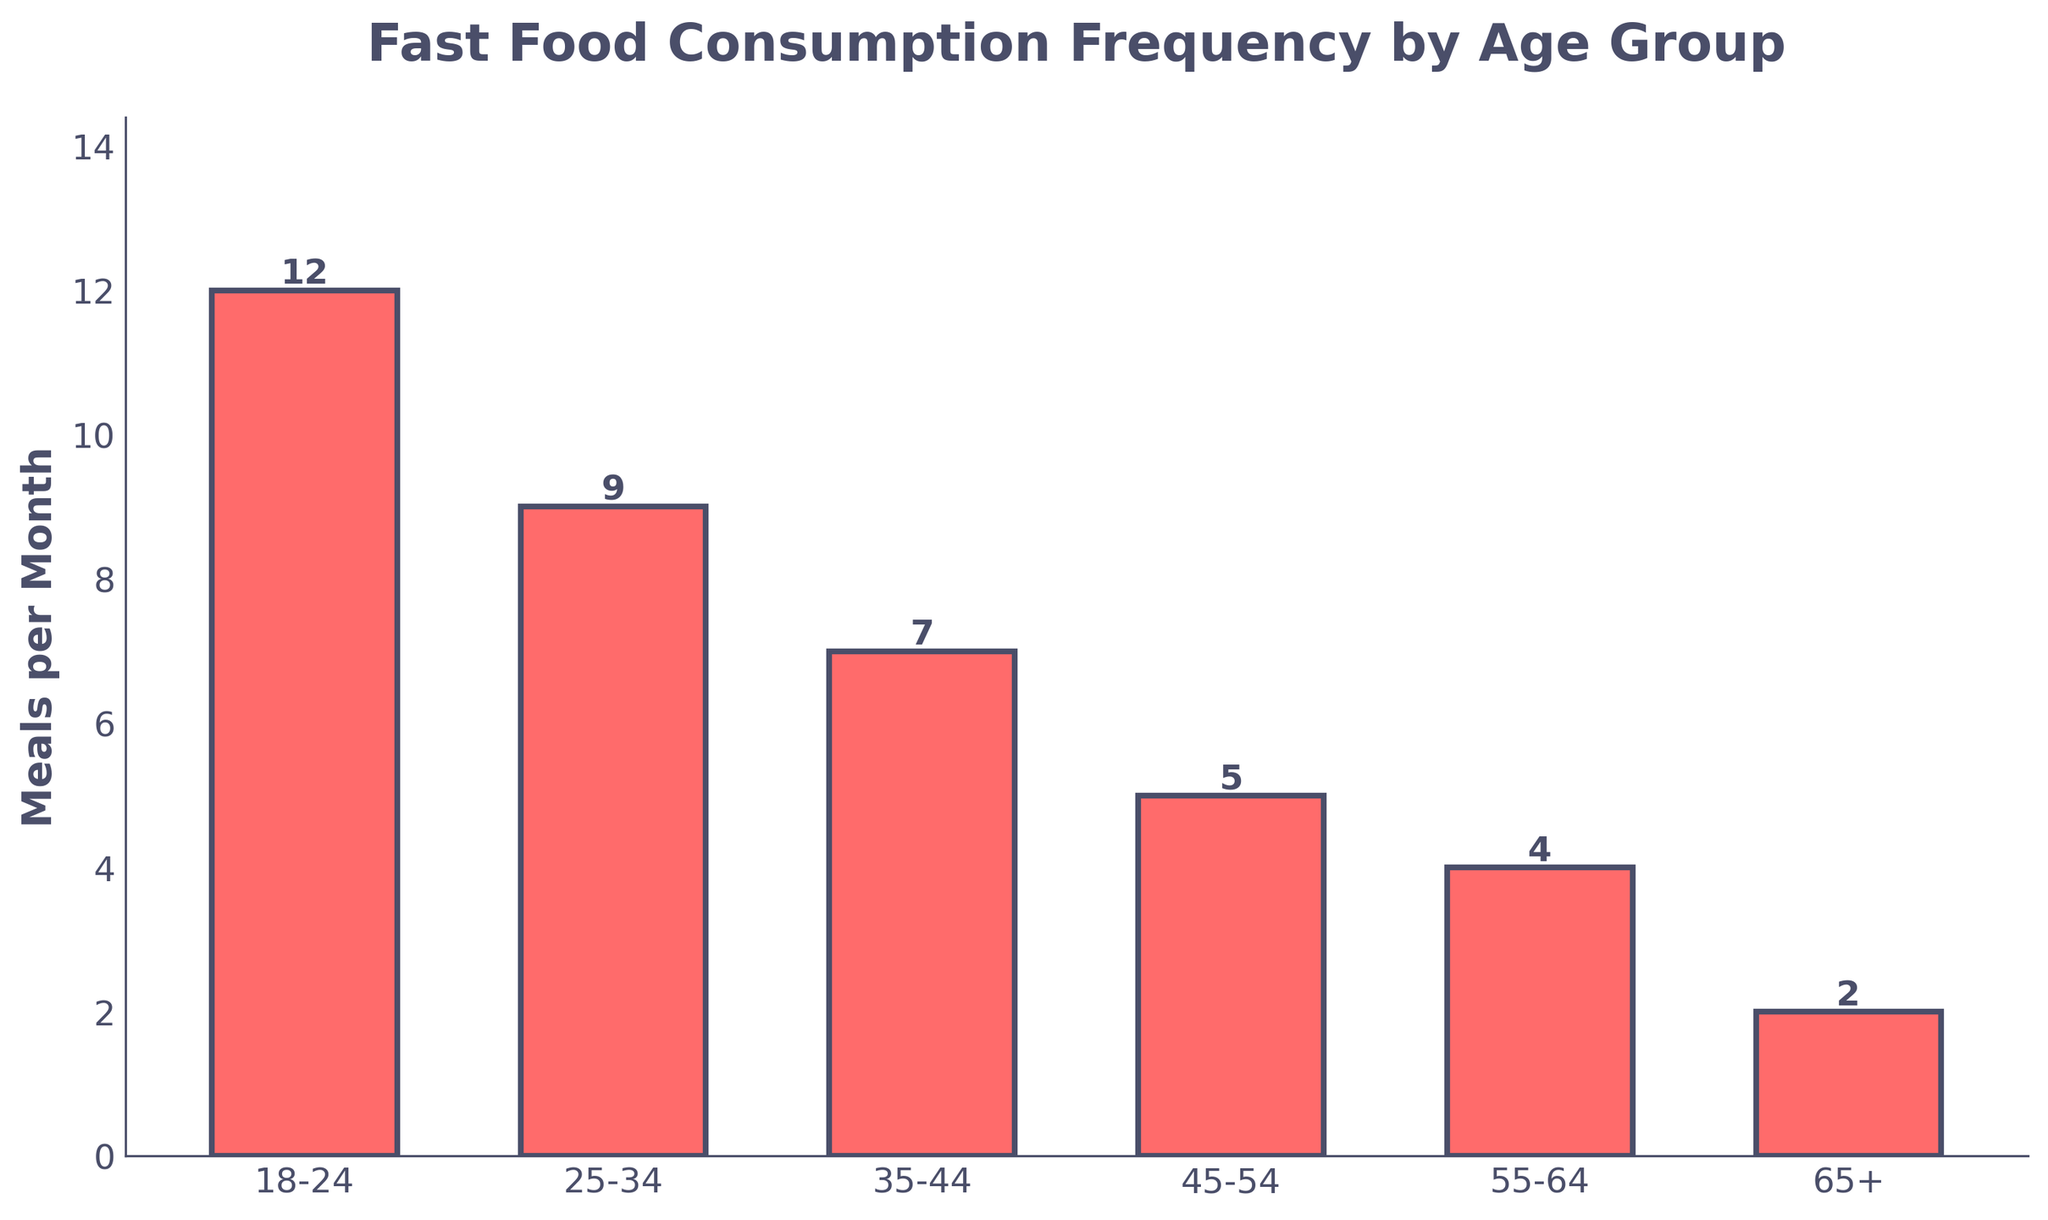What age group consumes the most fast food per month? By looking at the height of the bars, the age group with the tallest bar represents the highest fast food consumption. In this chart, the 18-24 age group has the tallest bar.
Answer: 18-24 Which age group consumes the least fast food per month? The age group with the shortest bar in the chart indicates the lowest consumption. The 65+ age group has the shortest bar.
Answer: 65+ How many more meals per month does the 18-24 age group consume compared to the 35-44 age group? The 18-24 age group consumes 12 meals per month, while the 35-44 age group consumes 7. Subtracting the two gives 12 - 7 = 5 meals per month.
Answer: 5 What is the total number of meals per month consumed by all age groups combined? Summing the meal values for all age groups: 12 (18-24) + 9 (25-34) + 7 (35-44) + 5 (45-54) + 4 (55-64) + 2 (65+). 12 + 9 + 7 + 5 + 4 + 2 = 39 meals per month.
Answer: 39 On average, how many meals per month do the age groups consume? The average is calculated by dividing the total number of meals by the number of age groups. The total is 39 meals, and there are 6 age groups: 39 / 6 = 6.5 meals per month.
Answer: 6.5 What is the difference in consumption between the 25-34 and 55-64 age groups? The 25-34 age group consumes 9 meals per month, while the 55-64 group consumes 4. The difference is 9 - 4 = 5 meals per month.
Answer: 5 Which age groups consume more than 6 meals per month? By inspecting the chart, the age groups consuming more than 6 meals per month have bars taller than the bar representing 6 meals. These age groups are 18-24 (12 meals), 25-34 (9 meals), and 35-44 (7 meals).
Answer: 18-24, 25-34, 35-44 What is the median number of meals consumed per month across the age groups? First, arrange the meal values in ascending order: 2, 4, 5, 7, 9, 12. The median value is the average of the middle two values (5 and 7): (5 + 7) / 2 = 6 meals per month.
Answer: 6 How many meals per month, on average, do the age groups above 45 consume? The age groups above 45 are 45-54, 55-64, and 65+. Their meals per month are 5, 4, and 2 respectively. The average is (5 + 4 + 2) / 3 = 11 / 3 = approximately 3.67 meals per month.
Answer: 3.67 What can be said about the trend in fast food consumption as age increases? By looking at the heights of the bars moving from left to right (younger to older age groups), the bar heights decrease. This indicates a downward trend in fast food consumption as age increases.
Answer: Decreasing trend 